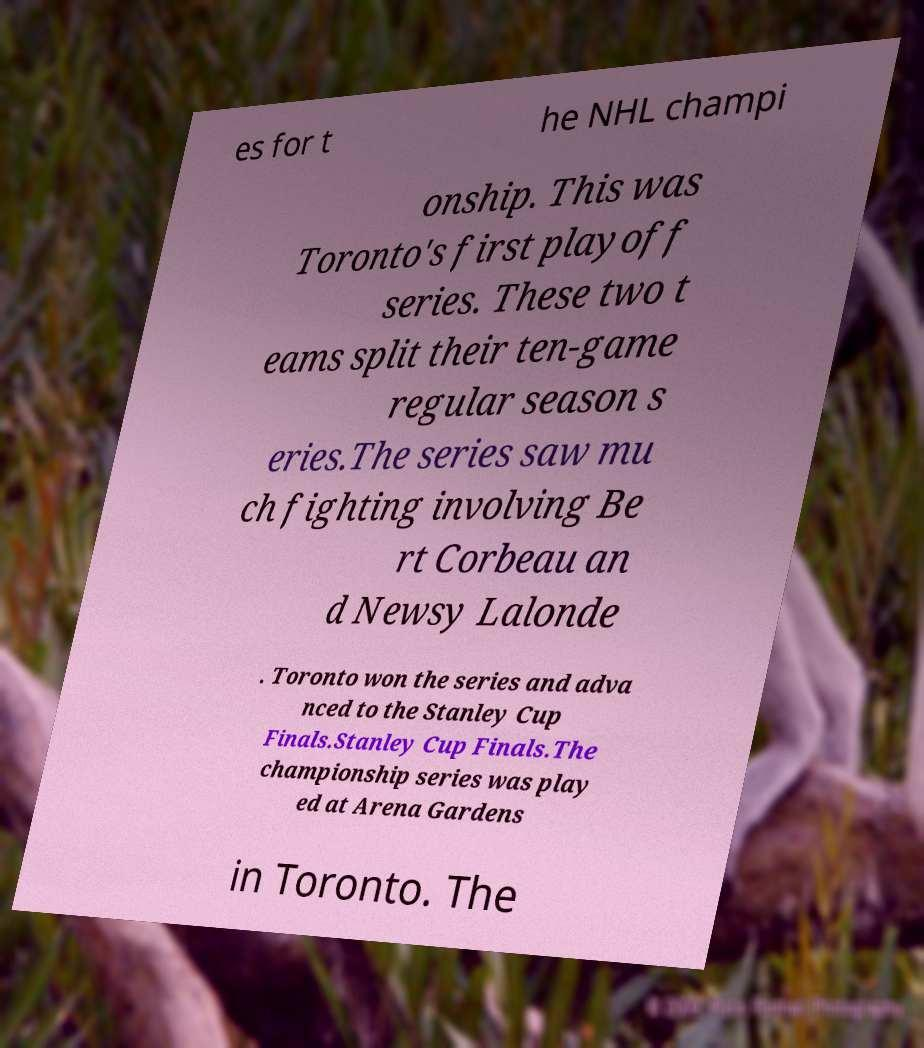Can you accurately transcribe the text from the provided image for me? es for t he NHL champi onship. This was Toronto's first playoff series. These two t eams split their ten-game regular season s eries.The series saw mu ch fighting involving Be rt Corbeau an d Newsy Lalonde . Toronto won the series and adva nced to the Stanley Cup Finals.Stanley Cup Finals.The championship series was play ed at Arena Gardens in Toronto. The 